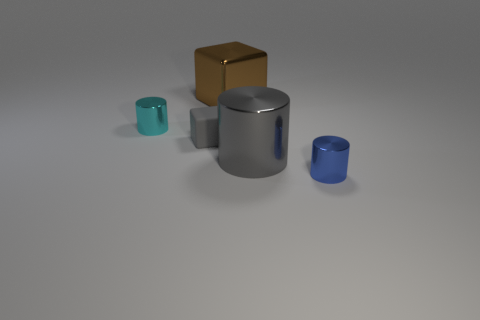Is there anything else of the same color as the large metal block?
Offer a terse response. No. There is another small shiny thing that is the same shape as the tiny cyan thing; what color is it?
Keep it short and to the point. Blue. Is the number of gray things to the right of the rubber object greater than the number of large blue matte blocks?
Offer a very short reply. Yes. The large metal cylinder that is on the right side of the tiny gray block is what color?
Provide a short and direct response. Gray. Do the gray metallic cylinder and the blue cylinder have the same size?
Your response must be concise. No. What size is the brown thing?
Offer a very short reply. Large. What is the shape of the big thing that is the same color as the matte cube?
Offer a terse response. Cylinder. Is the number of tiny shiny cylinders greater than the number of purple blocks?
Your response must be concise. Yes. What color is the small metal object behind the small metal thing in front of the cube in front of the cyan shiny cylinder?
Offer a very short reply. Cyan. Does the large thing to the right of the large cube have the same shape as the blue object?
Make the answer very short. Yes. 